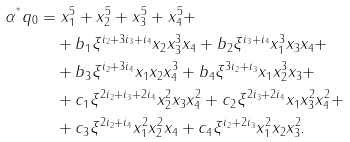Convert formula to latex. <formula><loc_0><loc_0><loc_500><loc_500>\alpha ^ { ^ { * } } q _ { 0 } & = x _ { 1 } ^ { 5 } + x _ { 2 } ^ { 5 } + x _ { 3 } ^ { 5 } + x _ { 4 } ^ { 5 } + \\ & \quad + b _ { 1 } \xi ^ { i _ { 2 } + 3 i _ { 3 } + i _ { 4 } } x _ { 2 } x _ { 3 } ^ { 3 } x _ { 4 } + b _ { 2 } \xi ^ { i _ { 3 } + i _ { 4 } } x _ { 1 } ^ { 3 } x _ { 3 } x _ { 4 } + \\ & \quad + b _ { 3 } \xi ^ { i _ { 2 } + 3 i _ { 4 } } x _ { 1 } x _ { 2 } x _ { 4 } ^ { 3 } + b _ { 4 } \xi ^ { 3 i _ { 2 } + i _ { 3 } } x _ { 1 } x _ { 2 } ^ { 3 } x _ { 3 } + \\ & \quad + c _ { 1 } \xi ^ { 2 i _ { 2 } + i _ { 3 } + 2 i _ { 4 } } x _ { 2 } ^ { 2 } x _ { 3 } x _ { 4 } ^ { 2 } + c _ { 2 } \xi ^ { 2 i _ { 3 } + 2 i _ { 4 } } x _ { 1 } x _ { 3 } ^ { 2 } x _ { 4 } ^ { 2 } + \\ & \quad + c _ { 3 } \xi ^ { 2 i _ { 2 } + i _ { 4 } } x _ { 1 } ^ { 2 } x _ { 2 } ^ { 2 } x _ { 4 } + c _ { 4 } \xi ^ { i _ { 2 } + 2 i _ { 3 } } x _ { 1 } ^ { 2 } x _ { 2 } x _ { 3 } ^ { 2 } \text {.}</formula> 